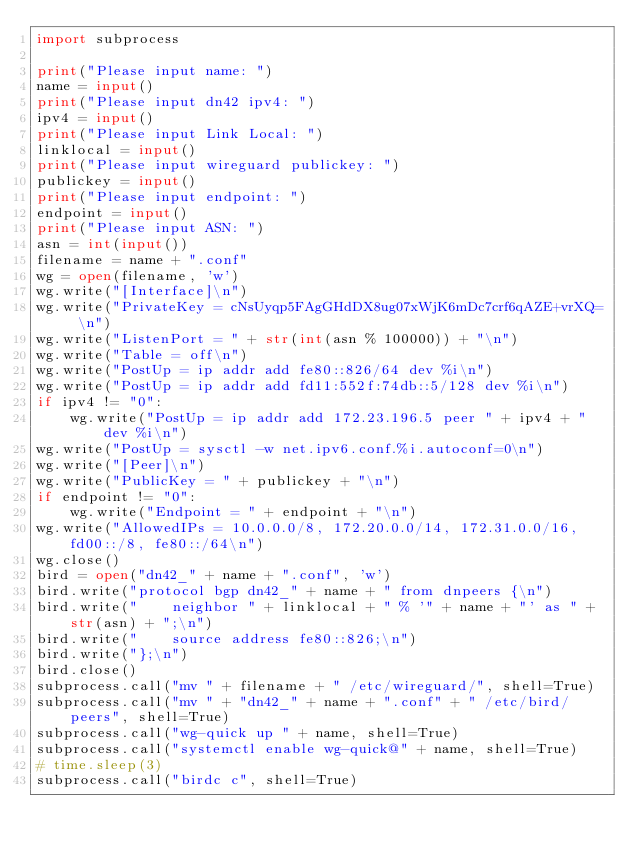Convert code to text. <code><loc_0><loc_0><loc_500><loc_500><_Python_>import subprocess

print("Please input name: ")
name = input()
print("Please input dn42 ipv4: ")
ipv4 = input()
print("Please input Link Local: ")
linklocal = input()
print("Please input wireguard publickey: ")
publickey = input()
print("Please input endpoint: ")
endpoint = input()
print("Please input ASN: ")
asn = int(input())
filename = name + ".conf"
wg = open(filename, 'w')
wg.write("[Interface]\n")
wg.write("PrivateKey = cNsUyqp5FAgGHdDX8ug07xWjK6mDc7crf6qAZE+vrXQ= \n")
wg.write("ListenPort = " + str(int(asn % 100000)) + "\n")
wg.write("Table = off\n")
wg.write("PostUp = ip addr add fe80::826/64 dev %i\n")
wg.write("PostUp = ip addr add fd11:552f:74db::5/128 dev %i\n")
if ipv4 != "0":
    wg.write("PostUp = ip addr add 172.23.196.5 peer " + ipv4 + " dev %i\n")
wg.write("PostUp = sysctl -w net.ipv6.conf.%i.autoconf=0\n")
wg.write("[Peer]\n")
wg.write("PublicKey = " + publickey + "\n")
if endpoint != "0":
    wg.write("Endpoint = " + endpoint + "\n")
wg.write("AllowedIPs = 10.0.0.0/8, 172.20.0.0/14, 172.31.0.0/16, fd00::/8, fe80::/64\n")
wg.close()
bird = open("dn42_" + name + ".conf", 'w')
bird.write("protocol bgp dn42_" + name + " from dnpeers {\n")
bird.write("    neighbor " + linklocal + " % '" + name + "' as " + str(asn) + ";\n")
bird.write("    source address fe80::826;\n")
bird.write("};\n")
bird.close()
subprocess.call("mv " + filename + " /etc/wireguard/", shell=True)
subprocess.call("mv " + "dn42_" + name + ".conf" + " /etc/bird/peers", shell=True)
subprocess.call("wg-quick up " + name, shell=True)
subprocess.call("systemctl enable wg-quick@" + name, shell=True)
# time.sleep(3)
subprocess.call("birdc c", shell=True)</code> 